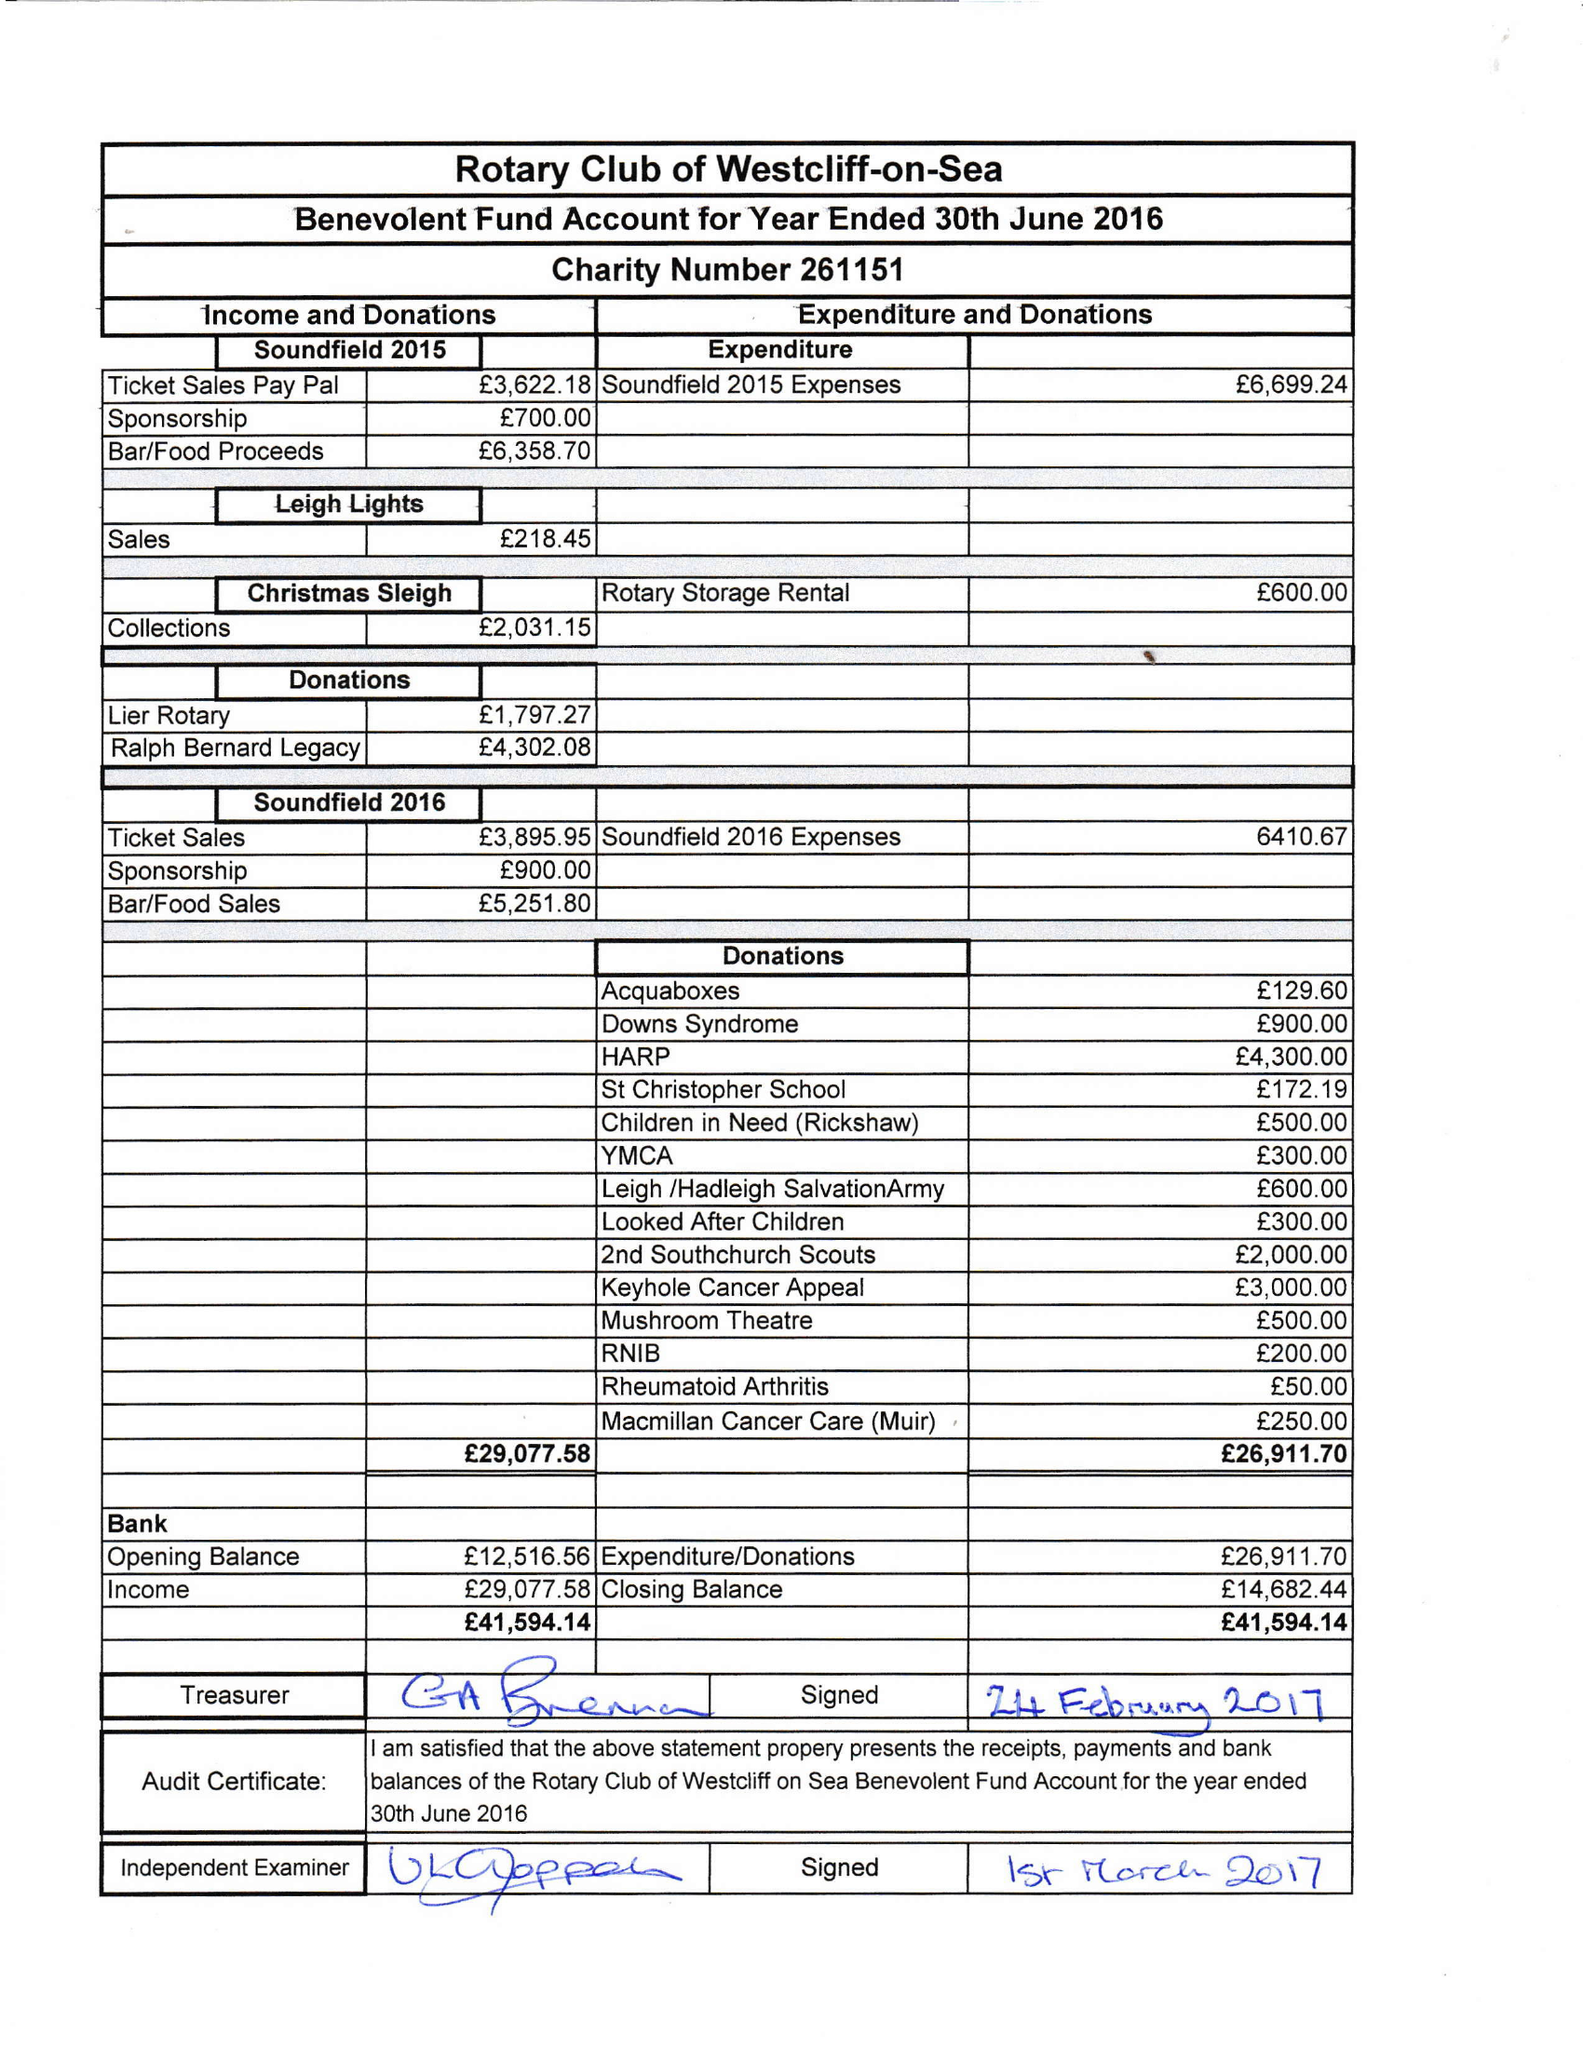What is the value for the address__postcode?
Answer the question using a single word or phrase. SS0 0BH 